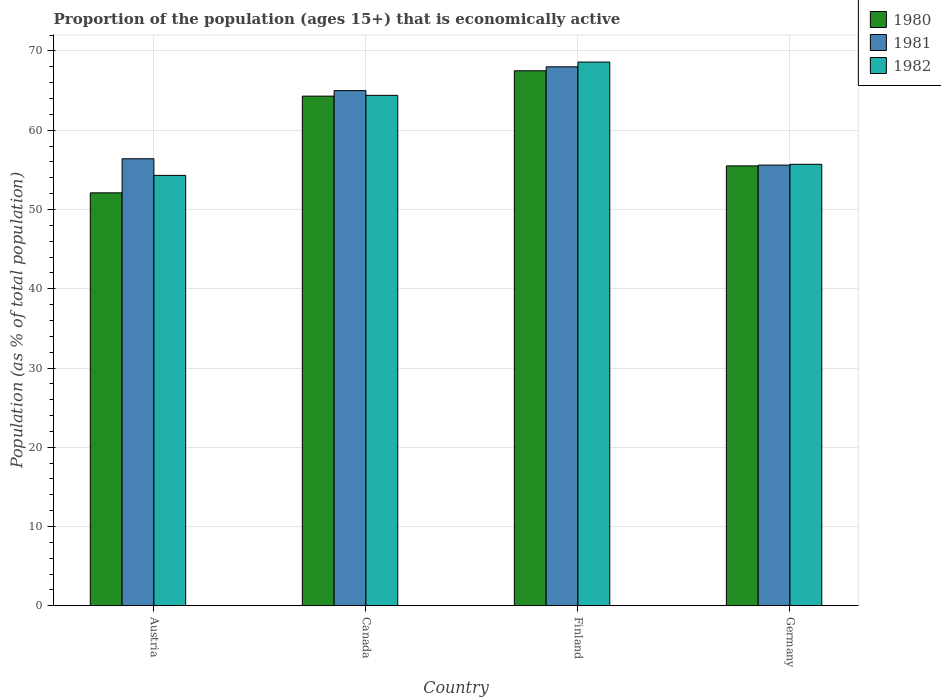How many different coloured bars are there?
Ensure brevity in your answer.  3. How many groups of bars are there?
Provide a short and direct response. 4. Are the number of bars on each tick of the X-axis equal?
Make the answer very short. Yes. How many bars are there on the 3rd tick from the left?
Offer a very short reply. 3. How many bars are there on the 1st tick from the right?
Make the answer very short. 3. What is the label of the 2nd group of bars from the left?
Your response must be concise. Canada. Across all countries, what is the maximum proportion of the population that is economically active in 1981?
Offer a very short reply. 68. Across all countries, what is the minimum proportion of the population that is economically active in 1980?
Your answer should be compact. 52.1. In which country was the proportion of the population that is economically active in 1982 maximum?
Give a very brief answer. Finland. In which country was the proportion of the population that is economically active in 1982 minimum?
Give a very brief answer. Austria. What is the total proportion of the population that is economically active in 1982 in the graph?
Offer a terse response. 243. What is the difference between the proportion of the population that is economically active in 1980 in Austria and that in Finland?
Keep it short and to the point. -15.4. What is the difference between the proportion of the population that is economically active in 1982 in Finland and the proportion of the population that is economically active in 1980 in Germany?
Make the answer very short. 13.1. What is the average proportion of the population that is economically active in 1981 per country?
Provide a short and direct response. 61.25. What is the difference between the proportion of the population that is economically active of/in 1982 and proportion of the population that is economically active of/in 1980 in Austria?
Your answer should be compact. 2.2. In how many countries, is the proportion of the population that is economically active in 1982 greater than 6 %?
Your response must be concise. 4. What is the ratio of the proportion of the population that is economically active in 1982 in Austria to that in Canada?
Ensure brevity in your answer.  0.84. What is the difference between the highest and the second highest proportion of the population that is economically active in 1980?
Your response must be concise. -3.2. What is the difference between the highest and the lowest proportion of the population that is economically active in 1980?
Provide a succinct answer. 15.4. What does the 3rd bar from the right in Austria represents?
Your answer should be very brief. 1980. Is it the case that in every country, the sum of the proportion of the population that is economically active in 1981 and proportion of the population that is economically active in 1982 is greater than the proportion of the population that is economically active in 1980?
Your answer should be very brief. Yes. How many bars are there?
Give a very brief answer. 12. Does the graph contain any zero values?
Make the answer very short. No. How are the legend labels stacked?
Provide a succinct answer. Vertical. What is the title of the graph?
Give a very brief answer. Proportion of the population (ages 15+) that is economically active. Does "1960" appear as one of the legend labels in the graph?
Ensure brevity in your answer.  No. What is the label or title of the Y-axis?
Make the answer very short. Population (as % of total population). What is the Population (as % of total population) in 1980 in Austria?
Your answer should be compact. 52.1. What is the Population (as % of total population) of 1981 in Austria?
Your answer should be very brief. 56.4. What is the Population (as % of total population) in 1982 in Austria?
Give a very brief answer. 54.3. What is the Population (as % of total population) in 1980 in Canada?
Offer a very short reply. 64.3. What is the Population (as % of total population) in 1982 in Canada?
Provide a succinct answer. 64.4. What is the Population (as % of total population) in 1980 in Finland?
Offer a very short reply. 67.5. What is the Population (as % of total population) in 1982 in Finland?
Offer a terse response. 68.6. What is the Population (as % of total population) of 1980 in Germany?
Your answer should be compact. 55.5. What is the Population (as % of total population) in 1981 in Germany?
Ensure brevity in your answer.  55.6. What is the Population (as % of total population) in 1982 in Germany?
Give a very brief answer. 55.7. Across all countries, what is the maximum Population (as % of total population) in 1980?
Ensure brevity in your answer.  67.5. Across all countries, what is the maximum Population (as % of total population) in 1982?
Provide a short and direct response. 68.6. Across all countries, what is the minimum Population (as % of total population) of 1980?
Your answer should be very brief. 52.1. Across all countries, what is the minimum Population (as % of total population) of 1981?
Give a very brief answer. 55.6. Across all countries, what is the minimum Population (as % of total population) in 1982?
Your answer should be very brief. 54.3. What is the total Population (as % of total population) of 1980 in the graph?
Provide a succinct answer. 239.4. What is the total Population (as % of total population) of 1981 in the graph?
Offer a terse response. 245. What is the total Population (as % of total population) in 1982 in the graph?
Provide a short and direct response. 243. What is the difference between the Population (as % of total population) of 1980 in Austria and that in Canada?
Give a very brief answer. -12.2. What is the difference between the Population (as % of total population) in 1981 in Austria and that in Canada?
Your answer should be compact. -8.6. What is the difference between the Population (as % of total population) in 1982 in Austria and that in Canada?
Your response must be concise. -10.1. What is the difference between the Population (as % of total population) in 1980 in Austria and that in Finland?
Ensure brevity in your answer.  -15.4. What is the difference between the Population (as % of total population) of 1982 in Austria and that in Finland?
Make the answer very short. -14.3. What is the difference between the Population (as % of total population) in 1982 in Austria and that in Germany?
Keep it short and to the point. -1.4. What is the difference between the Population (as % of total population) in 1981 in Canada and that in Finland?
Your answer should be very brief. -3. What is the difference between the Population (as % of total population) in 1981 in Canada and that in Germany?
Your response must be concise. 9.4. What is the difference between the Population (as % of total population) in 1982 in Canada and that in Germany?
Offer a very short reply. 8.7. What is the difference between the Population (as % of total population) of 1980 in Finland and that in Germany?
Offer a very short reply. 12. What is the difference between the Population (as % of total population) in 1982 in Finland and that in Germany?
Provide a succinct answer. 12.9. What is the difference between the Population (as % of total population) of 1980 in Austria and the Population (as % of total population) of 1981 in Canada?
Keep it short and to the point. -12.9. What is the difference between the Population (as % of total population) in 1980 in Austria and the Population (as % of total population) in 1982 in Canada?
Your response must be concise. -12.3. What is the difference between the Population (as % of total population) of 1981 in Austria and the Population (as % of total population) of 1982 in Canada?
Provide a short and direct response. -8. What is the difference between the Population (as % of total population) of 1980 in Austria and the Population (as % of total population) of 1981 in Finland?
Your answer should be very brief. -15.9. What is the difference between the Population (as % of total population) in 1980 in Austria and the Population (as % of total population) in 1982 in Finland?
Offer a terse response. -16.5. What is the difference between the Population (as % of total population) in 1981 in Austria and the Population (as % of total population) in 1982 in Finland?
Give a very brief answer. -12.2. What is the difference between the Population (as % of total population) in 1980 in Austria and the Population (as % of total population) in 1981 in Germany?
Your answer should be very brief. -3.5. What is the difference between the Population (as % of total population) in 1980 in Canada and the Population (as % of total population) in 1981 in Finland?
Offer a very short reply. -3.7. What is the difference between the Population (as % of total population) in 1980 in Canada and the Population (as % of total population) in 1982 in Finland?
Your answer should be very brief. -4.3. What is the difference between the Population (as % of total population) of 1980 in Canada and the Population (as % of total population) of 1981 in Germany?
Offer a very short reply. 8.7. What is the difference between the Population (as % of total population) of 1981 in Canada and the Population (as % of total population) of 1982 in Germany?
Ensure brevity in your answer.  9.3. What is the difference between the Population (as % of total population) in 1980 in Finland and the Population (as % of total population) in 1982 in Germany?
Provide a succinct answer. 11.8. What is the average Population (as % of total population) in 1980 per country?
Your response must be concise. 59.85. What is the average Population (as % of total population) of 1981 per country?
Provide a short and direct response. 61.25. What is the average Population (as % of total population) in 1982 per country?
Your response must be concise. 60.75. What is the difference between the Population (as % of total population) in 1980 and Population (as % of total population) in 1981 in Austria?
Your response must be concise. -4.3. What is the difference between the Population (as % of total population) of 1981 and Population (as % of total population) of 1982 in Austria?
Your answer should be compact. 2.1. What is the difference between the Population (as % of total population) in 1980 and Population (as % of total population) in 1982 in Canada?
Your response must be concise. -0.1. What is the difference between the Population (as % of total population) of 1981 and Population (as % of total population) of 1982 in Canada?
Keep it short and to the point. 0.6. What is the difference between the Population (as % of total population) of 1980 and Population (as % of total population) of 1981 in Finland?
Give a very brief answer. -0.5. What is the difference between the Population (as % of total population) in 1981 and Population (as % of total population) in 1982 in Finland?
Your answer should be compact. -0.6. What is the difference between the Population (as % of total population) in 1980 and Population (as % of total population) in 1981 in Germany?
Give a very brief answer. -0.1. What is the difference between the Population (as % of total population) of 1981 and Population (as % of total population) of 1982 in Germany?
Offer a terse response. -0.1. What is the ratio of the Population (as % of total population) of 1980 in Austria to that in Canada?
Your answer should be very brief. 0.81. What is the ratio of the Population (as % of total population) of 1981 in Austria to that in Canada?
Provide a short and direct response. 0.87. What is the ratio of the Population (as % of total population) in 1982 in Austria to that in Canada?
Your response must be concise. 0.84. What is the ratio of the Population (as % of total population) of 1980 in Austria to that in Finland?
Give a very brief answer. 0.77. What is the ratio of the Population (as % of total population) in 1981 in Austria to that in Finland?
Your answer should be compact. 0.83. What is the ratio of the Population (as % of total population) in 1982 in Austria to that in Finland?
Give a very brief answer. 0.79. What is the ratio of the Population (as % of total population) of 1980 in Austria to that in Germany?
Your response must be concise. 0.94. What is the ratio of the Population (as % of total population) in 1981 in Austria to that in Germany?
Offer a terse response. 1.01. What is the ratio of the Population (as % of total population) in 1982 in Austria to that in Germany?
Provide a short and direct response. 0.97. What is the ratio of the Population (as % of total population) of 1980 in Canada to that in Finland?
Give a very brief answer. 0.95. What is the ratio of the Population (as % of total population) in 1981 in Canada to that in Finland?
Your response must be concise. 0.96. What is the ratio of the Population (as % of total population) in 1982 in Canada to that in Finland?
Ensure brevity in your answer.  0.94. What is the ratio of the Population (as % of total population) in 1980 in Canada to that in Germany?
Make the answer very short. 1.16. What is the ratio of the Population (as % of total population) in 1981 in Canada to that in Germany?
Ensure brevity in your answer.  1.17. What is the ratio of the Population (as % of total population) of 1982 in Canada to that in Germany?
Keep it short and to the point. 1.16. What is the ratio of the Population (as % of total population) of 1980 in Finland to that in Germany?
Offer a very short reply. 1.22. What is the ratio of the Population (as % of total population) of 1981 in Finland to that in Germany?
Keep it short and to the point. 1.22. What is the ratio of the Population (as % of total population) of 1982 in Finland to that in Germany?
Your answer should be very brief. 1.23. What is the difference between the highest and the second highest Population (as % of total population) of 1980?
Give a very brief answer. 3.2. What is the difference between the highest and the second highest Population (as % of total population) of 1981?
Your answer should be very brief. 3. What is the difference between the highest and the second highest Population (as % of total population) of 1982?
Offer a terse response. 4.2. What is the difference between the highest and the lowest Population (as % of total population) in 1980?
Your response must be concise. 15.4. What is the difference between the highest and the lowest Population (as % of total population) in 1981?
Offer a very short reply. 12.4. What is the difference between the highest and the lowest Population (as % of total population) of 1982?
Your response must be concise. 14.3. 